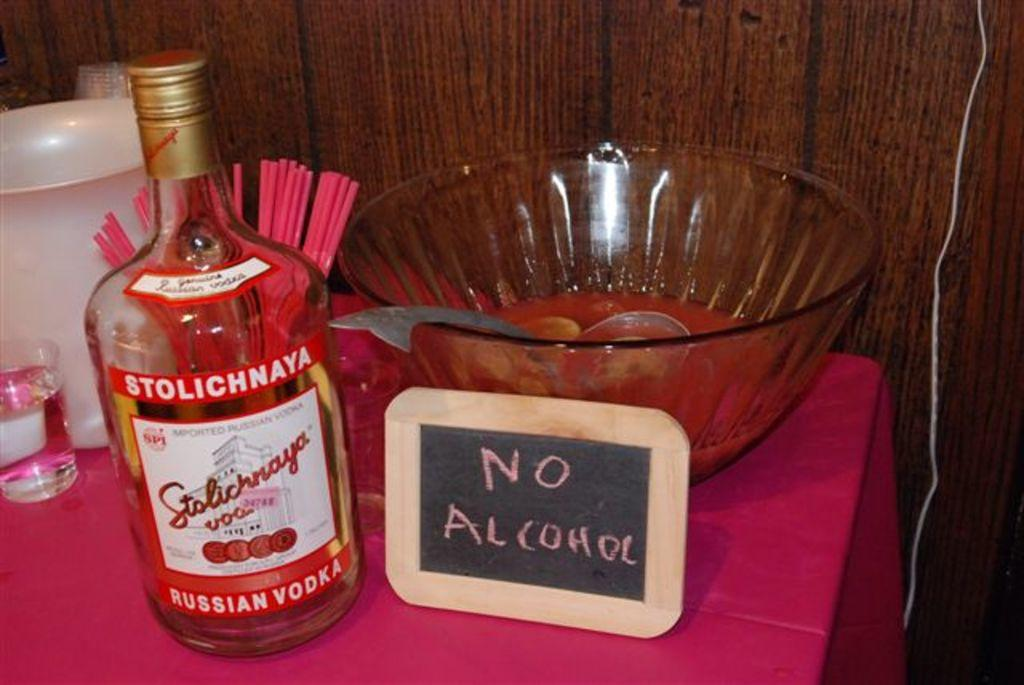<image>
Create a compact narrative representing the image presented. Stolichnaya Russian Vodka that contains no alcohol sitting on a purple tablecloth. 